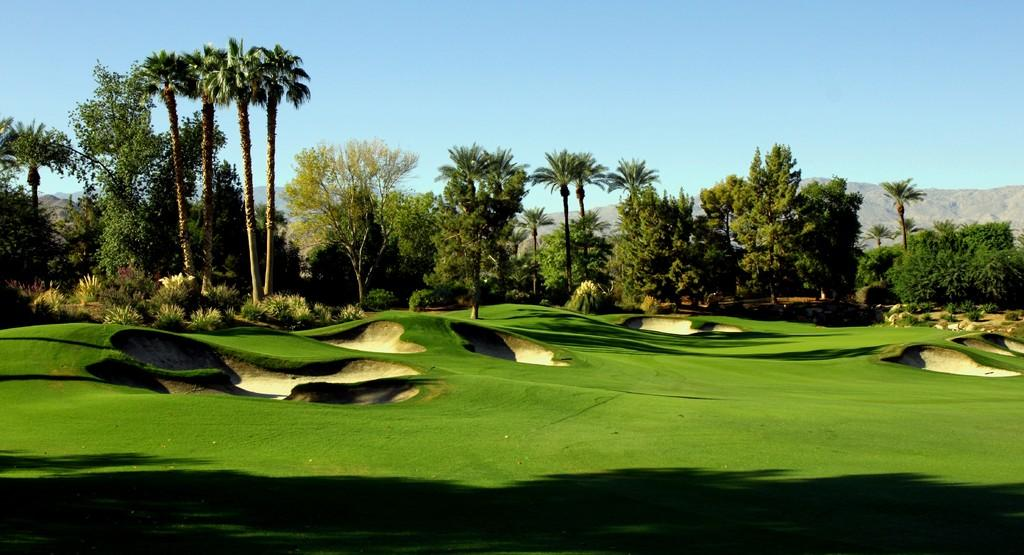What type of vegetation can be seen in the image? There is grass, plants, and trees in the image. What type of natural landform is visible in the image? There are mountains in the image. What part of the natural environment is visible in the image? The sky is visible in the image. Where might this image have been taken, considering the presence of grass, plants, and trees? The image may have been taken in a park. What time of day might the image have been taken? The image may have been taken during the day, given the visibility of the sky and natural light. What type of office furniture can be seen in the image? There is no office furniture present in the image; it features natural elements such as grass, plants, trees, mountains, and the sky. What type of trousers is the person wearing in the image? There is no person present in the image, so it is not possible to determine what type of trousers they might be wearing. 